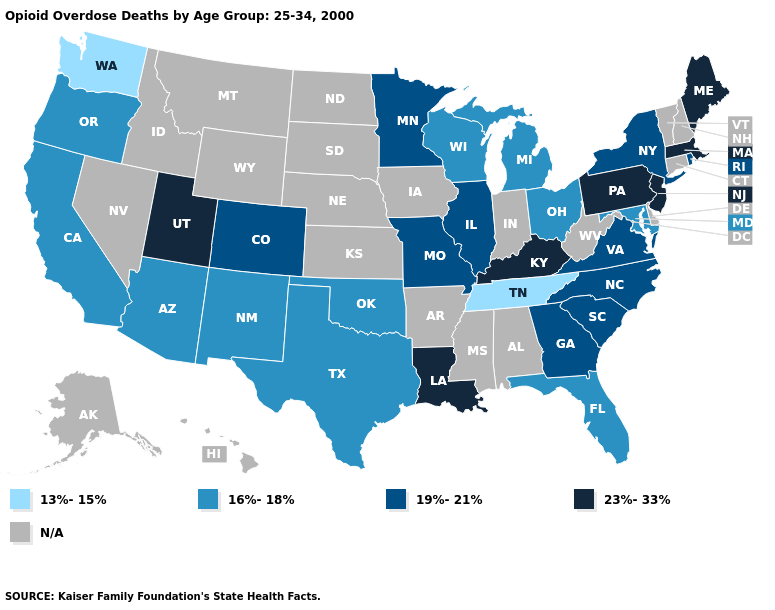Name the states that have a value in the range 23%-33%?
Answer briefly. Kentucky, Louisiana, Maine, Massachusetts, New Jersey, Pennsylvania, Utah. What is the value of Rhode Island?
Answer briefly. 19%-21%. Which states have the highest value in the USA?
Write a very short answer. Kentucky, Louisiana, Maine, Massachusetts, New Jersey, Pennsylvania, Utah. What is the highest value in states that border Oklahoma?
Keep it brief. 19%-21%. Does New York have the highest value in the Northeast?
Concise answer only. No. Which states have the highest value in the USA?
Be succinct. Kentucky, Louisiana, Maine, Massachusetts, New Jersey, Pennsylvania, Utah. Name the states that have a value in the range 19%-21%?
Give a very brief answer. Colorado, Georgia, Illinois, Minnesota, Missouri, New York, North Carolina, Rhode Island, South Carolina, Virginia. Among the states that border Ohio , does Michigan have the highest value?
Write a very short answer. No. Among the states that border Vermont , which have the lowest value?
Write a very short answer. New York. Name the states that have a value in the range 23%-33%?
Short answer required. Kentucky, Louisiana, Maine, Massachusetts, New Jersey, Pennsylvania, Utah. What is the value of Oklahoma?
Be succinct. 16%-18%. Does Rhode Island have the highest value in the Northeast?
Answer briefly. No. Does Washington have the lowest value in the USA?
Quick response, please. Yes. Is the legend a continuous bar?
Quick response, please. No. Does New Jersey have the highest value in the USA?
Give a very brief answer. Yes. 